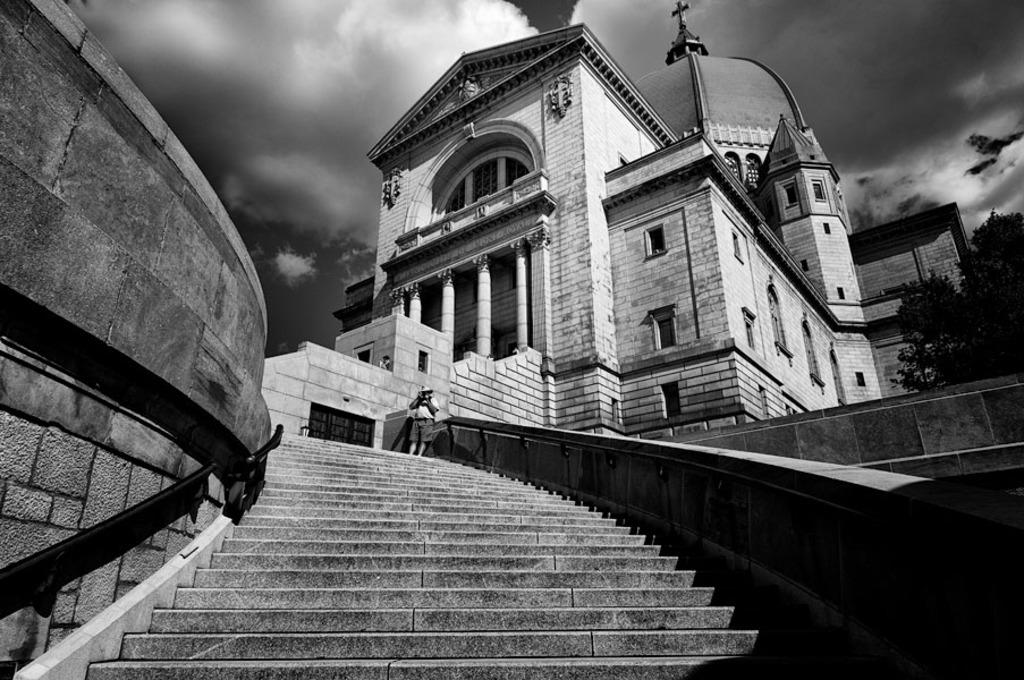What type of structure is present in the image? There is a staircase in the image. What can be seen in the background of the image? There are buildings and trees in the background of the image. What type of note is being played on the staircase in the image? There is no note or musical instrument present on the staircase in the image. What is the condition of the minister in the image? There is no minister present in the image. 